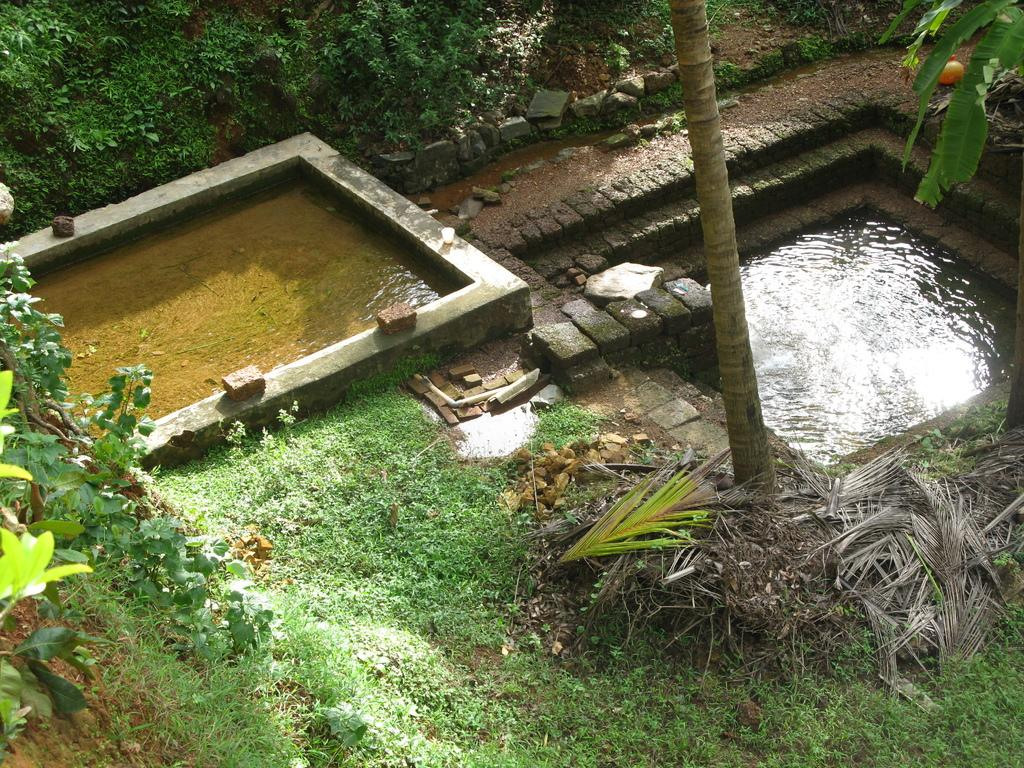What type of vegetation can be seen in the image? There are trees in the image. What type of ground cover is present in the image? There is grass in the image. What type of material is present in the image? There are stones and bricks in the image. What type of terrain is visible in the image? There is sand in the image. What natural element is visible in the image? There is water visible in the image. Where is the farmer standing in the image? There is no farmer present in the image. What type of shelter is visible in the image? There is no tent or any other type of shelter visible in the image. 